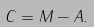Convert formula to latex. <formula><loc_0><loc_0><loc_500><loc_500>C = M - A .</formula> 